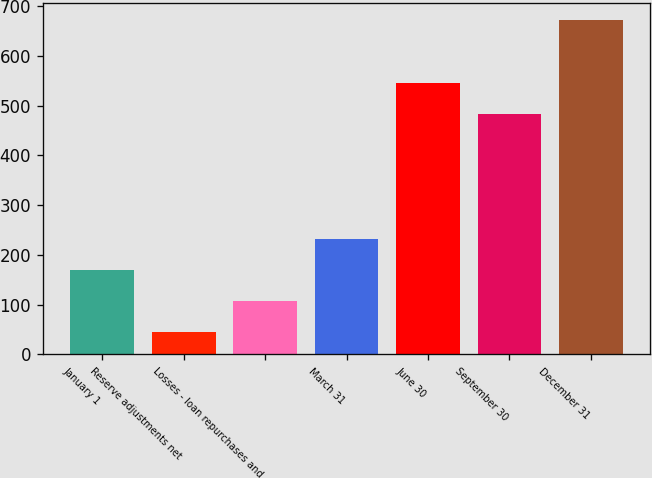Convert chart. <chart><loc_0><loc_0><loc_500><loc_500><bar_chart><fcel>January 1<fcel>Reserve adjustments net<fcel>Losses - loan repurchases and<fcel>March 31<fcel>June 30<fcel>September 30<fcel>December 31<nl><fcel>169.6<fcel>44<fcel>106.8<fcel>232.4<fcel>545.8<fcel>483<fcel>672<nl></chart> 